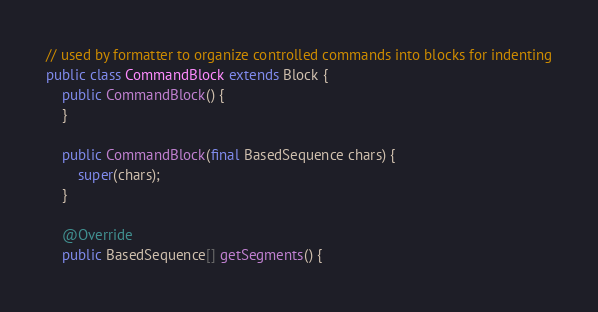<code> <loc_0><loc_0><loc_500><loc_500><_Java_>// used by formatter to organize controlled commands into blocks for indenting
public class CommandBlock extends Block {
    public CommandBlock() {
    }

    public CommandBlock(final BasedSequence chars) {
        super(chars);
    }

    @Override
    public BasedSequence[] getSegments() {</code> 